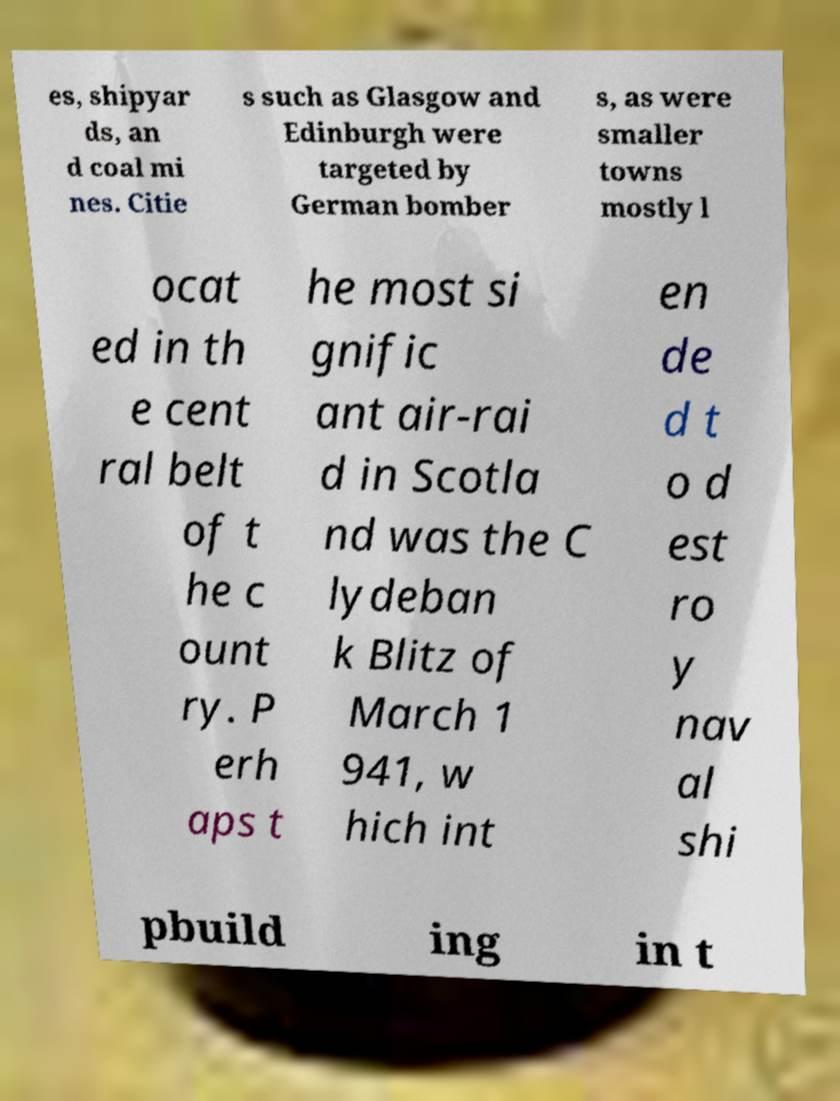There's text embedded in this image that I need extracted. Can you transcribe it verbatim? es, shipyar ds, an d coal mi nes. Citie s such as Glasgow and Edinburgh were targeted by German bomber s, as were smaller towns mostly l ocat ed in th e cent ral belt of t he c ount ry. P erh aps t he most si gnific ant air-rai d in Scotla nd was the C lydeban k Blitz of March 1 941, w hich int en de d t o d est ro y nav al shi pbuild ing in t 